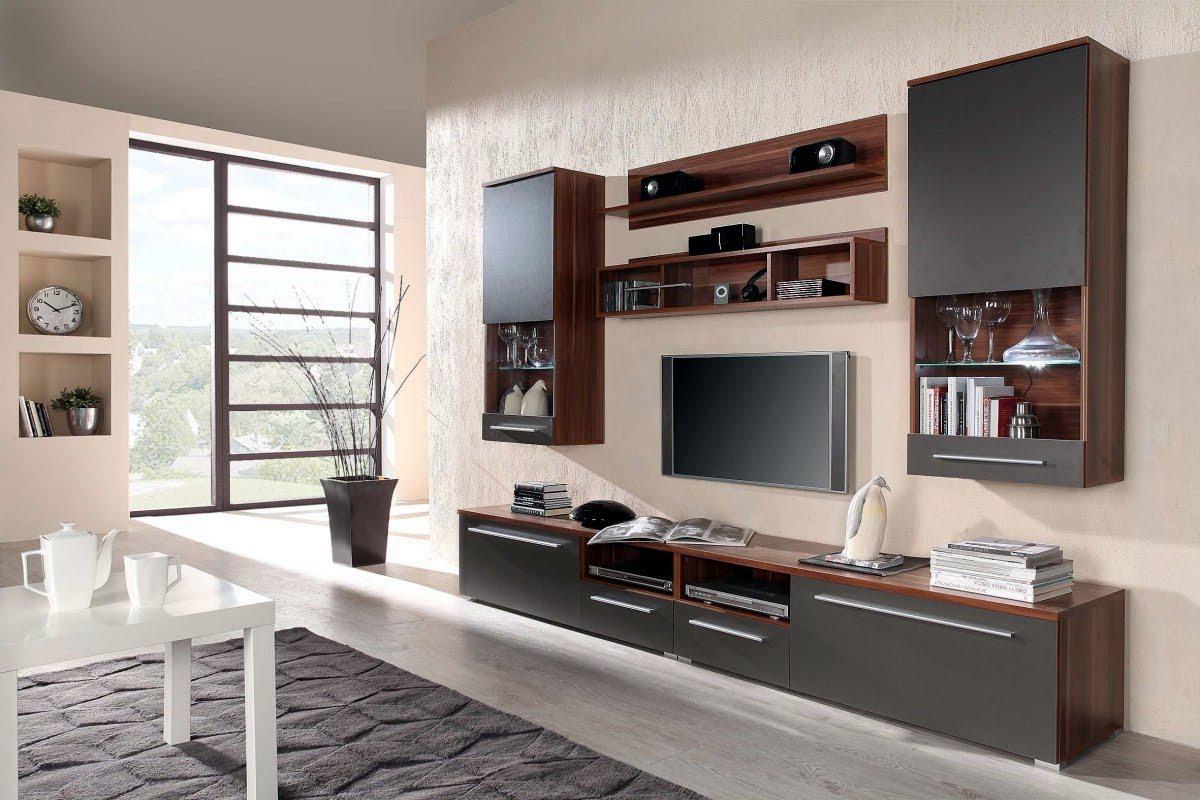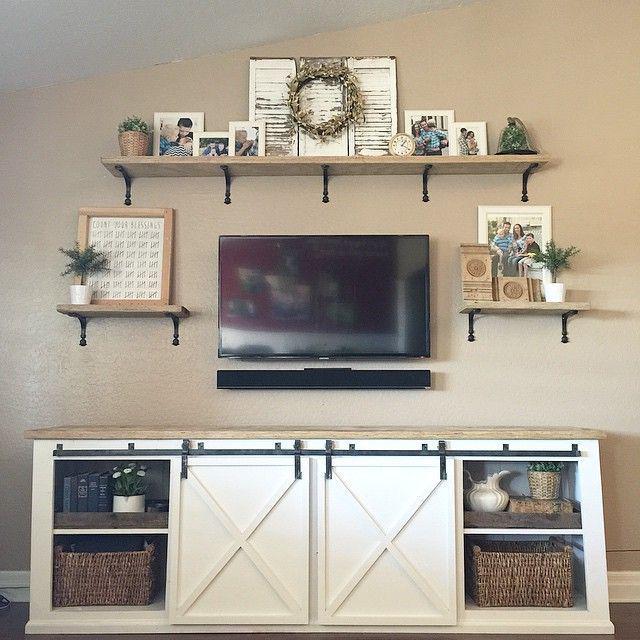The first image is the image on the left, the second image is the image on the right. For the images shown, is this caption "At least one television is on." true? Answer yes or no. No. The first image is the image on the left, the second image is the image on the right. Considering the images on both sides, is "In at least one image there is a TV mounted to a shelf with a tall back over a long cabinet." valid? Answer yes or no. No. 